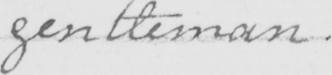Please provide the text content of this handwritten line. gentleman . 